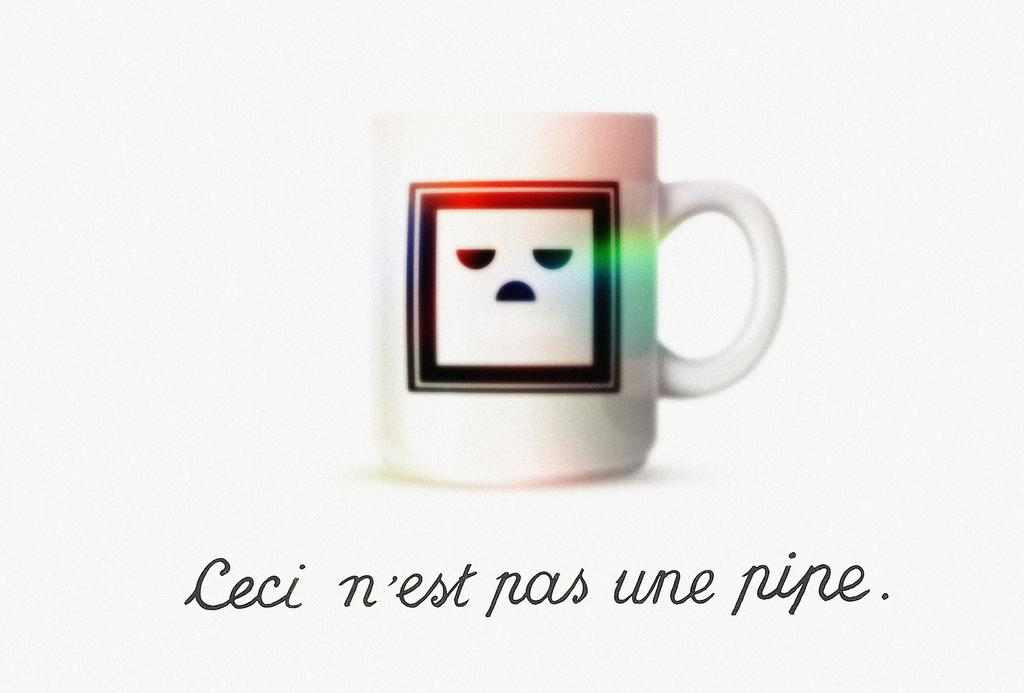<image>
Create a compact narrative representing the image presented. a mug with an unhappy face decal on it reading ceci n'est pas une pipe 